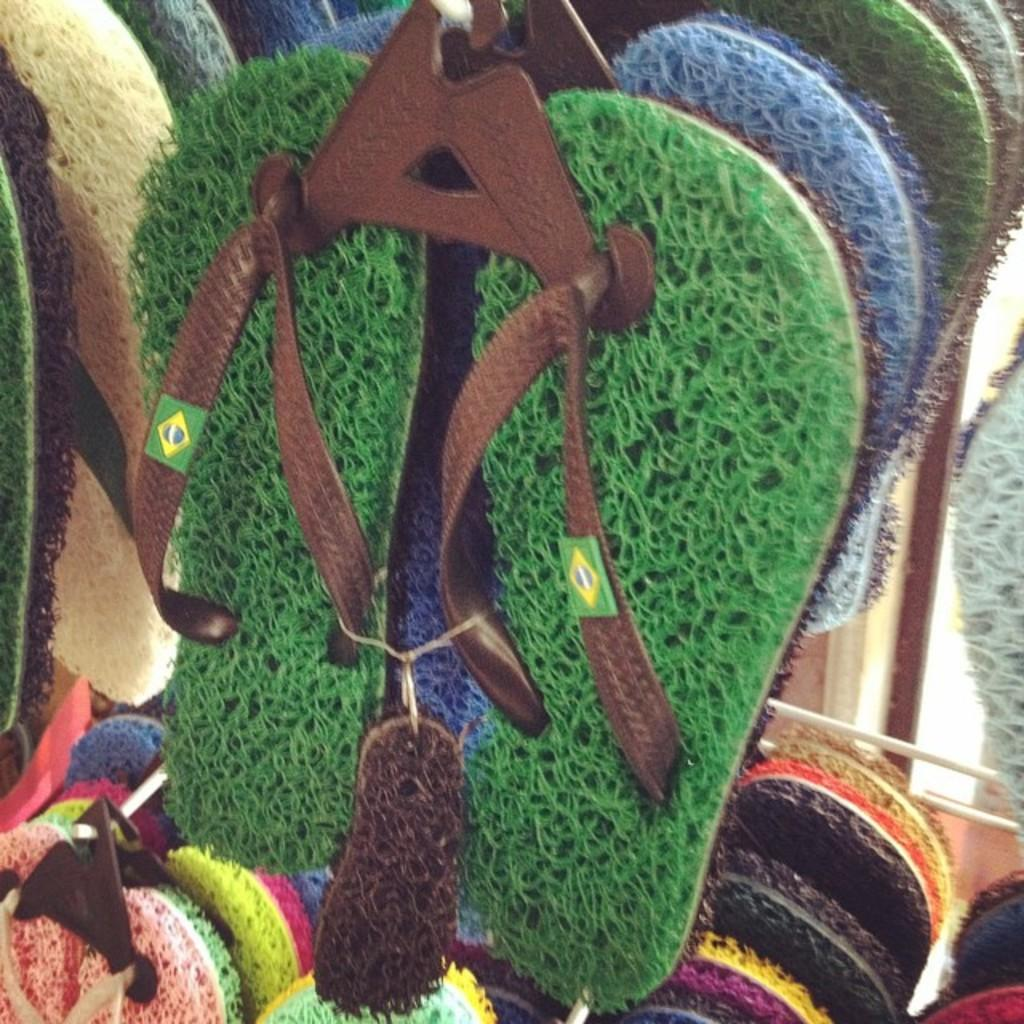What type of footwear is present in the image? There are slippers in the image. What other objects can be seen in the image? There are hangers visible in the image. What can be seen in the background on the right side of the image? There is a wall visible in the background on the right side of the image. What rule is being enforced by the rake in the image? There is no rake present in the image, so no rule is being enforced by a rake. 